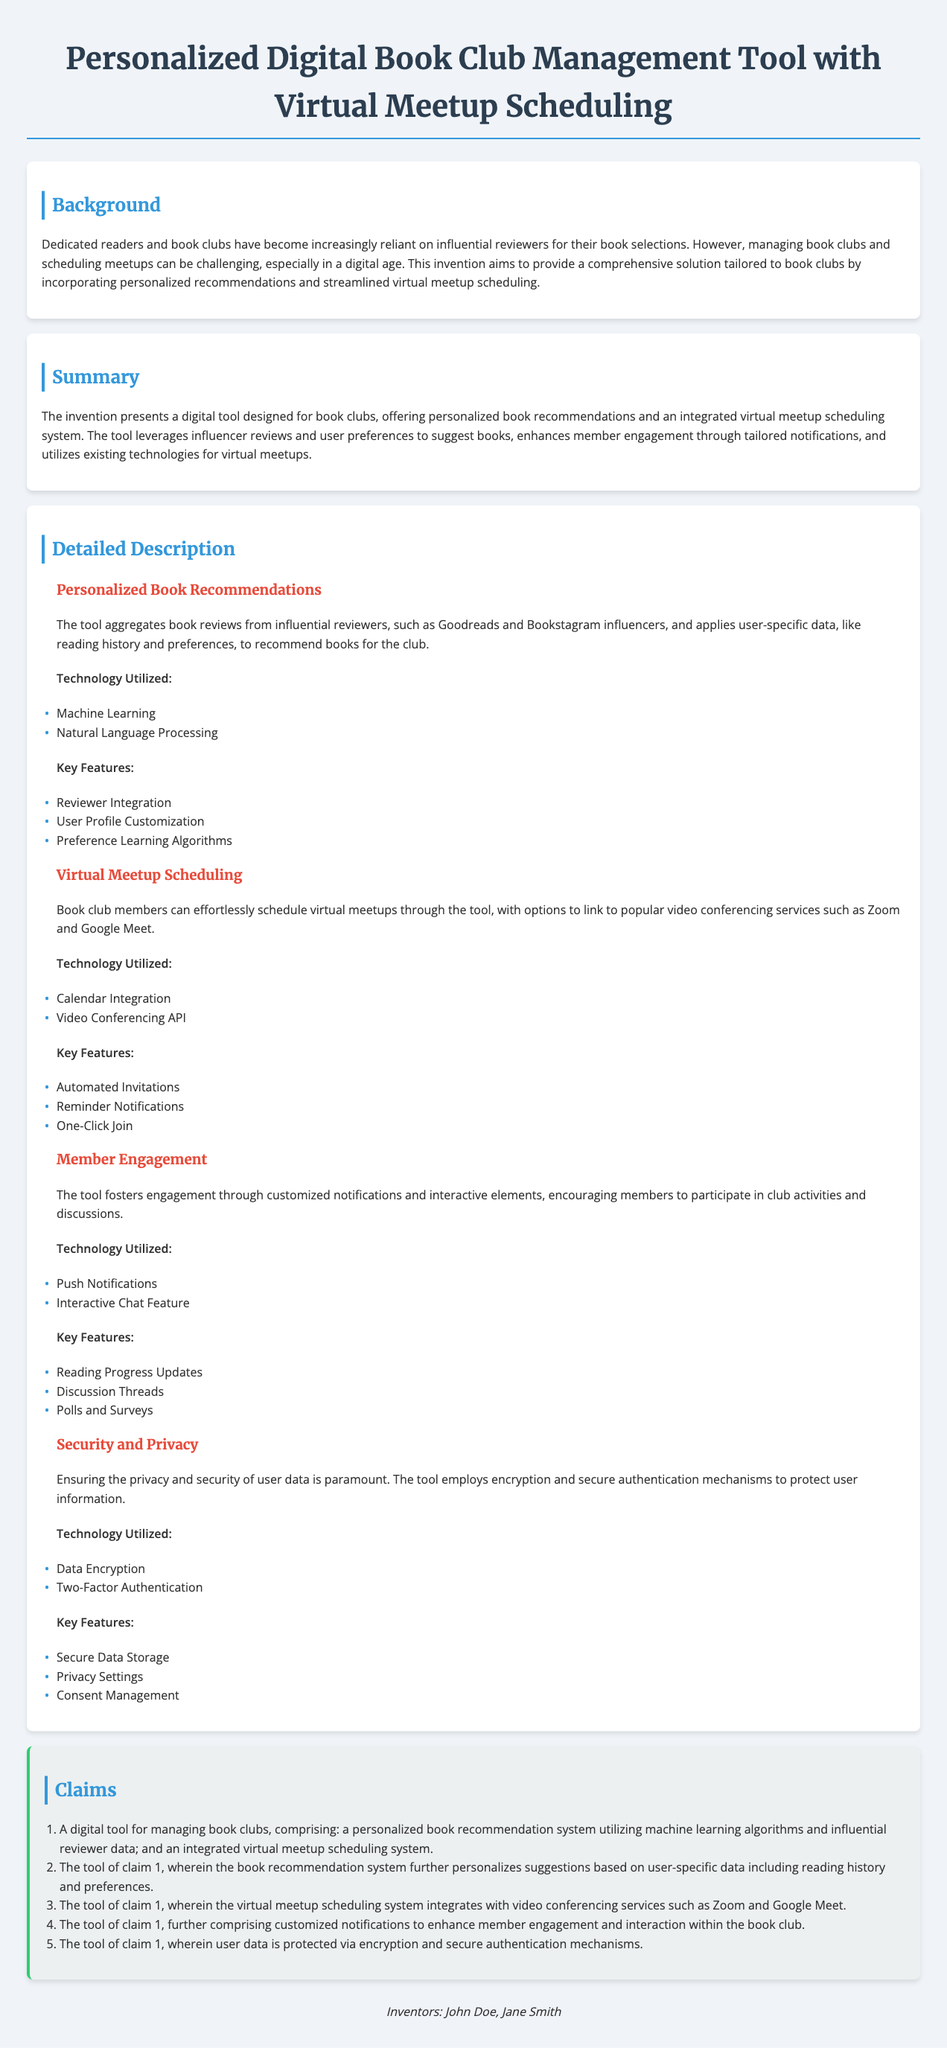What is the title of the patent? The title indicates the subject of the patent application, which is a Personalized Digital Book Club Management Tool with Virtual Meetup Scheduling.
Answer: Personalized Digital Book Club Management Tool with Virtual Meetup Scheduling Who are the inventors? The document specifies the names of the inventors involved in this patent application.
Answer: John Doe, Jane Smith What technology is used for personalized book recommendations? The document lists specific technologies utilized in the invention, including machine learning.
Answer: Machine Learning How does the tool facilitate virtual meetups? The detailed description mentions the integration with popular video conferencing services as a key feature.
Answer: Integration with video conferencing services What feature enhances member engagement in the tool? The key features section under Member Engagement outlines specific elements that foster participation.
Answer: Customized notifications What does the tool employ to protect user data? The section about Security and Privacy specifies protections employed for user data.
Answer: Encryption What is one technology utilized for automated invitations? The document outlines the technology used within the Virtual Meetup Scheduling section.
Answer: Video Conferencing API How many claims are presented in the patent? The claims section lists the total number of claims made in this application, which can be counted.
Answer: Five 